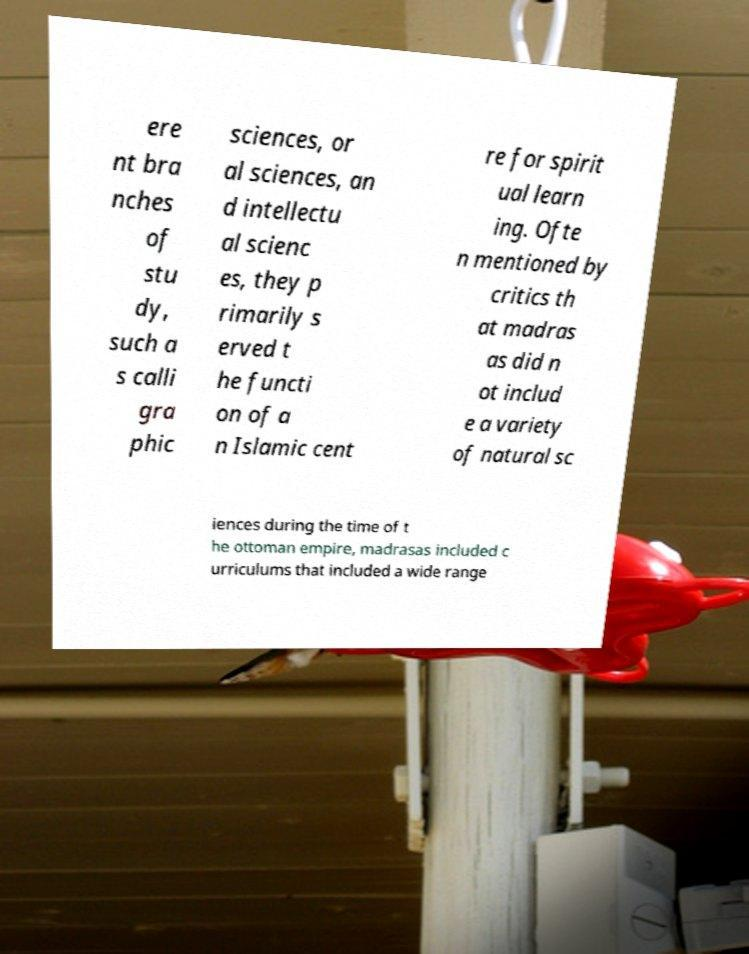Please identify and transcribe the text found in this image. ere nt bra nches of stu dy, such a s calli gra phic sciences, or al sciences, an d intellectu al scienc es, they p rimarily s erved t he functi on of a n Islamic cent re for spirit ual learn ing. Ofte n mentioned by critics th at madras as did n ot includ e a variety of natural sc iences during the time of t he ottoman empire, madrasas included c urriculums that included a wide range 